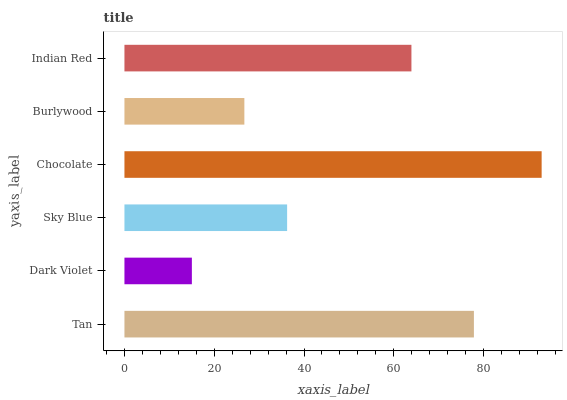Is Dark Violet the minimum?
Answer yes or no. Yes. Is Chocolate the maximum?
Answer yes or no. Yes. Is Sky Blue the minimum?
Answer yes or no. No. Is Sky Blue the maximum?
Answer yes or no. No. Is Sky Blue greater than Dark Violet?
Answer yes or no. Yes. Is Dark Violet less than Sky Blue?
Answer yes or no. Yes. Is Dark Violet greater than Sky Blue?
Answer yes or no. No. Is Sky Blue less than Dark Violet?
Answer yes or no. No. Is Indian Red the high median?
Answer yes or no. Yes. Is Sky Blue the low median?
Answer yes or no. Yes. Is Chocolate the high median?
Answer yes or no. No. Is Chocolate the low median?
Answer yes or no. No. 